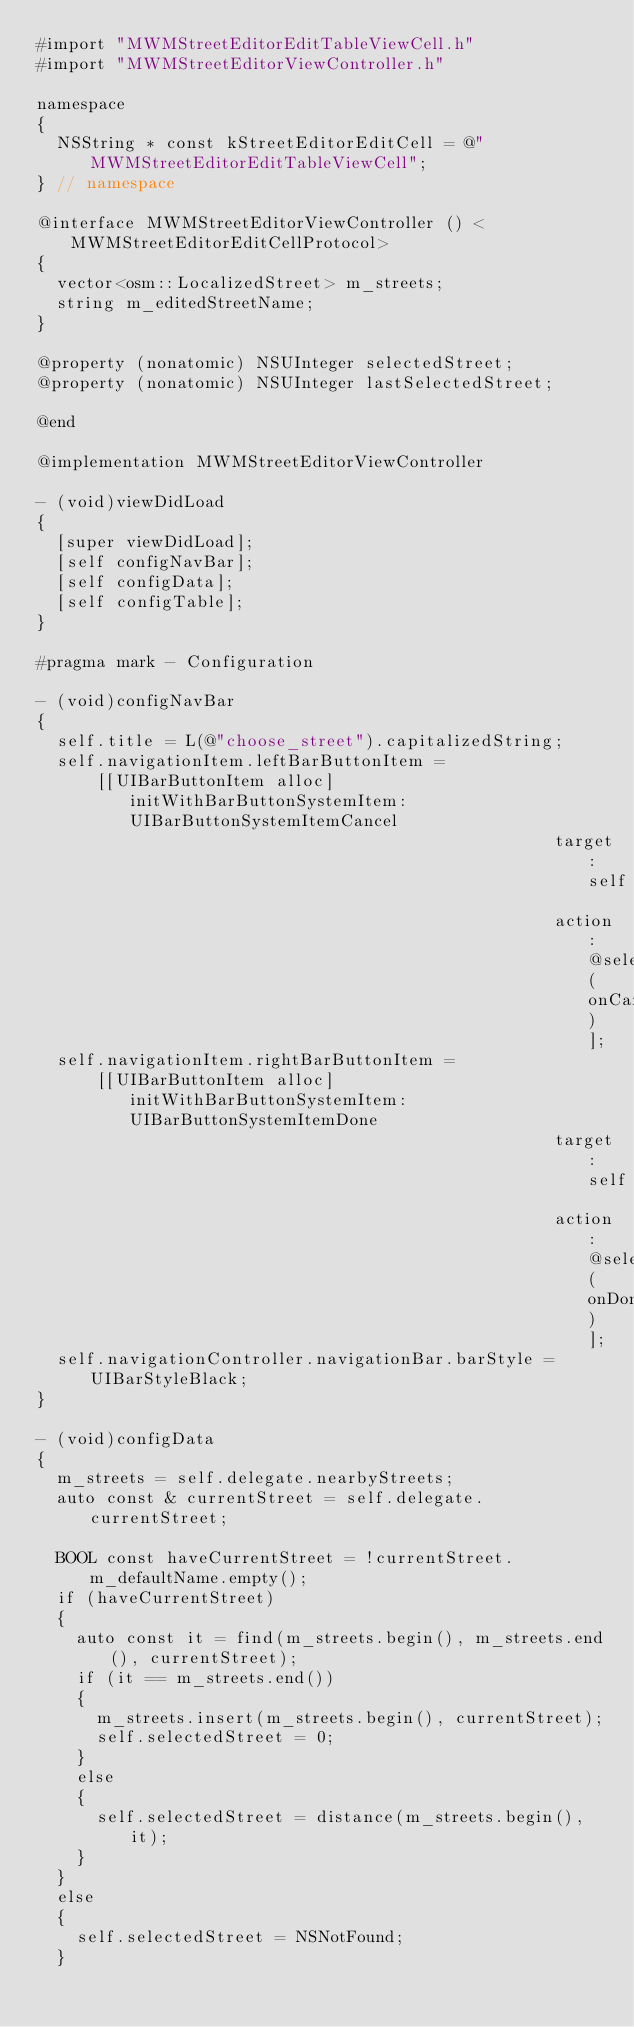Convert code to text. <code><loc_0><loc_0><loc_500><loc_500><_ObjectiveC_>#import "MWMStreetEditorEditTableViewCell.h"
#import "MWMStreetEditorViewController.h"

namespace
{
  NSString * const kStreetEditorEditCell = @"MWMStreetEditorEditTableViewCell";
} // namespace

@interface MWMStreetEditorViewController () <MWMStreetEditorEditCellProtocol>
{
  vector<osm::LocalizedStreet> m_streets;
  string m_editedStreetName;
}

@property (nonatomic) NSUInteger selectedStreet;
@property (nonatomic) NSUInteger lastSelectedStreet;

@end

@implementation MWMStreetEditorViewController

- (void)viewDidLoad
{
  [super viewDidLoad];
  [self configNavBar];
  [self configData];
  [self configTable];
}

#pragma mark - Configuration

- (void)configNavBar
{
  self.title = L(@"choose_street").capitalizedString;
  self.navigationItem.leftBarButtonItem =
      [[UIBarButtonItem alloc] initWithBarButtonSystemItem:UIBarButtonSystemItemCancel
                                                    target:self
                                                    action:@selector(onCancel)];
  self.navigationItem.rightBarButtonItem =
      [[UIBarButtonItem alloc] initWithBarButtonSystemItem:UIBarButtonSystemItemDone
                                                    target:self
                                                    action:@selector(onDone)];
  self.navigationController.navigationBar.barStyle = UIBarStyleBlack;
}

- (void)configData
{
  m_streets = self.delegate.nearbyStreets;
  auto const & currentStreet = self.delegate.currentStreet;

  BOOL const haveCurrentStreet = !currentStreet.m_defaultName.empty();
  if (haveCurrentStreet)
  {
    auto const it = find(m_streets.begin(), m_streets.end(), currentStreet);
    if (it == m_streets.end())
    {
      m_streets.insert(m_streets.begin(), currentStreet);
      self.selectedStreet = 0;
    }
    else
    {
      self.selectedStreet = distance(m_streets.begin(), it);
    }
  }
  else
  {
    self.selectedStreet = NSNotFound;
  }</code> 